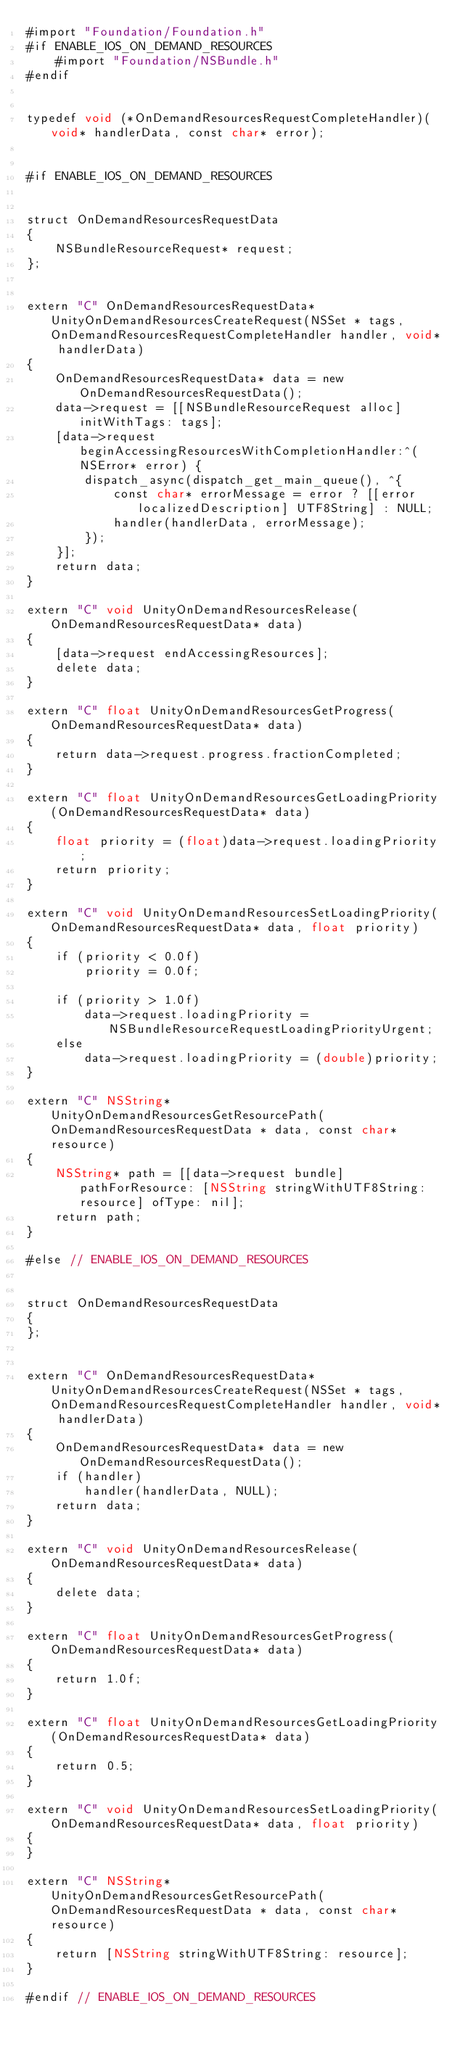<code> <loc_0><loc_0><loc_500><loc_500><_ObjectiveC_>#import "Foundation/Foundation.h"
#if ENABLE_IOS_ON_DEMAND_RESOURCES
    #import "Foundation/NSBundle.h"
#endif


typedef void (*OnDemandResourcesRequestCompleteHandler)(void* handlerData, const char* error);


#if ENABLE_IOS_ON_DEMAND_RESOURCES


struct OnDemandResourcesRequestData
{
    NSBundleResourceRequest* request;
};


extern "C" OnDemandResourcesRequestData* UnityOnDemandResourcesCreateRequest(NSSet * tags, OnDemandResourcesRequestCompleteHandler handler, void* handlerData)
{
    OnDemandResourcesRequestData* data = new OnDemandResourcesRequestData();
    data->request = [[NSBundleResourceRequest alloc] initWithTags: tags];
    [data->request beginAccessingResourcesWithCompletionHandler:^(NSError* error) {
        dispatch_async(dispatch_get_main_queue(), ^{
            const char* errorMessage = error ? [[error localizedDescription] UTF8String] : NULL;
            handler(handlerData, errorMessage);
        });
    }];
    return data;
}

extern "C" void UnityOnDemandResourcesRelease(OnDemandResourcesRequestData* data)
{
    [data->request endAccessingResources];
    delete data;
}

extern "C" float UnityOnDemandResourcesGetProgress(OnDemandResourcesRequestData* data)
{
    return data->request.progress.fractionCompleted;
}

extern "C" float UnityOnDemandResourcesGetLoadingPriority(OnDemandResourcesRequestData* data)
{
    float priority = (float)data->request.loadingPriority;
    return priority;
}

extern "C" void UnityOnDemandResourcesSetLoadingPriority(OnDemandResourcesRequestData* data, float priority)
{
    if (priority < 0.0f)
        priority = 0.0f;

    if (priority > 1.0f)
        data->request.loadingPriority = NSBundleResourceRequestLoadingPriorityUrgent;
    else
        data->request.loadingPriority = (double)priority;
}

extern "C" NSString* UnityOnDemandResourcesGetResourcePath(OnDemandResourcesRequestData * data, const char* resource)
{
    NSString* path = [[data->request bundle] pathForResource: [NSString stringWithUTF8String: resource] ofType: nil];
    return path;
}

#else // ENABLE_IOS_ON_DEMAND_RESOURCES


struct OnDemandResourcesRequestData
{
};


extern "C" OnDemandResourcesRequestData* UnityOnDemandResourcesCreateRequest(NSSet * tags, OnDemandResourcesRequestCompleteHandler handler, void* handlerData)
{
    OnDemandResourcesRequestData* data = new OnDemandResourcesRequestData();
    if (handler)
        handler(handlerData, NULL);
    return data;
}

extern "C" void UnityOnDemandResourcesRelease(OnDemandResourcesRequestData* data)
{
    delete data;
}

extern "C" float UnityOnDemandResourcesGetProgress(OnDemandResourcesRequestData* data)
{
    return 1.0f;
}

extern "C" float UnityOnDemandResourcesGetLoadingPriority(OnDemandResourcesRequestData* data)
{
    return 0.5;
}

extern "C" void UnityOnDemandResourcesSetLoadingPriority(OnDemandResourcesRequestData* data, float priority)
{
}

extern "C" NSString* UnityOnDemandResourcesGetResourcePath(OnDemandResourcesRequestData * data, const char* resource)
{
    return [NSString stringWithUTF8String: resource];
}

#endif // ENABLE_IOS_ON_DEMAND_RESOURCES
</code> 